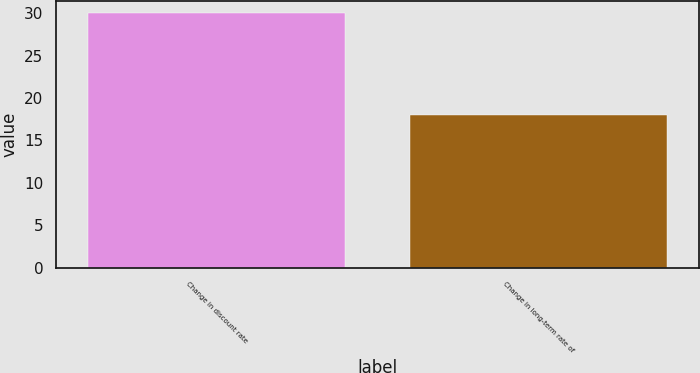Convert chart. <chart><loc_0><loc_0><loc_500><loc_500><bar_chart><fcel>Change in discount rate<fcel>Change in long-term rate of<nl><fcel>30<fcel>18<nl></chart> 